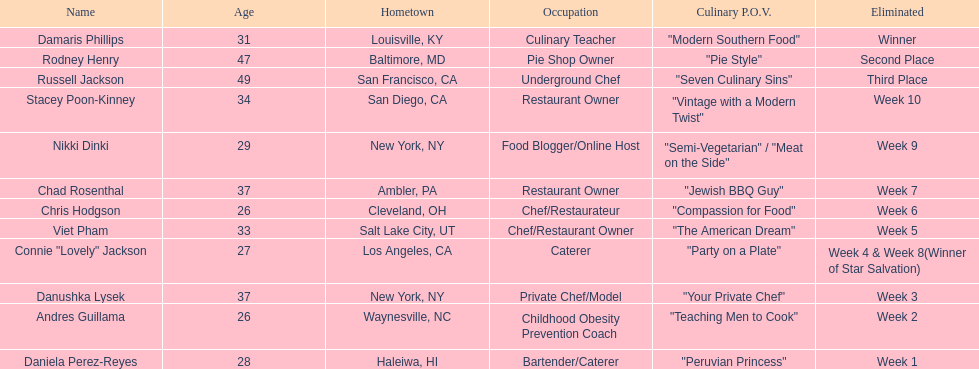Between nikki dinki and viet pham, who was the first to be eliminated? Viet Pham. 